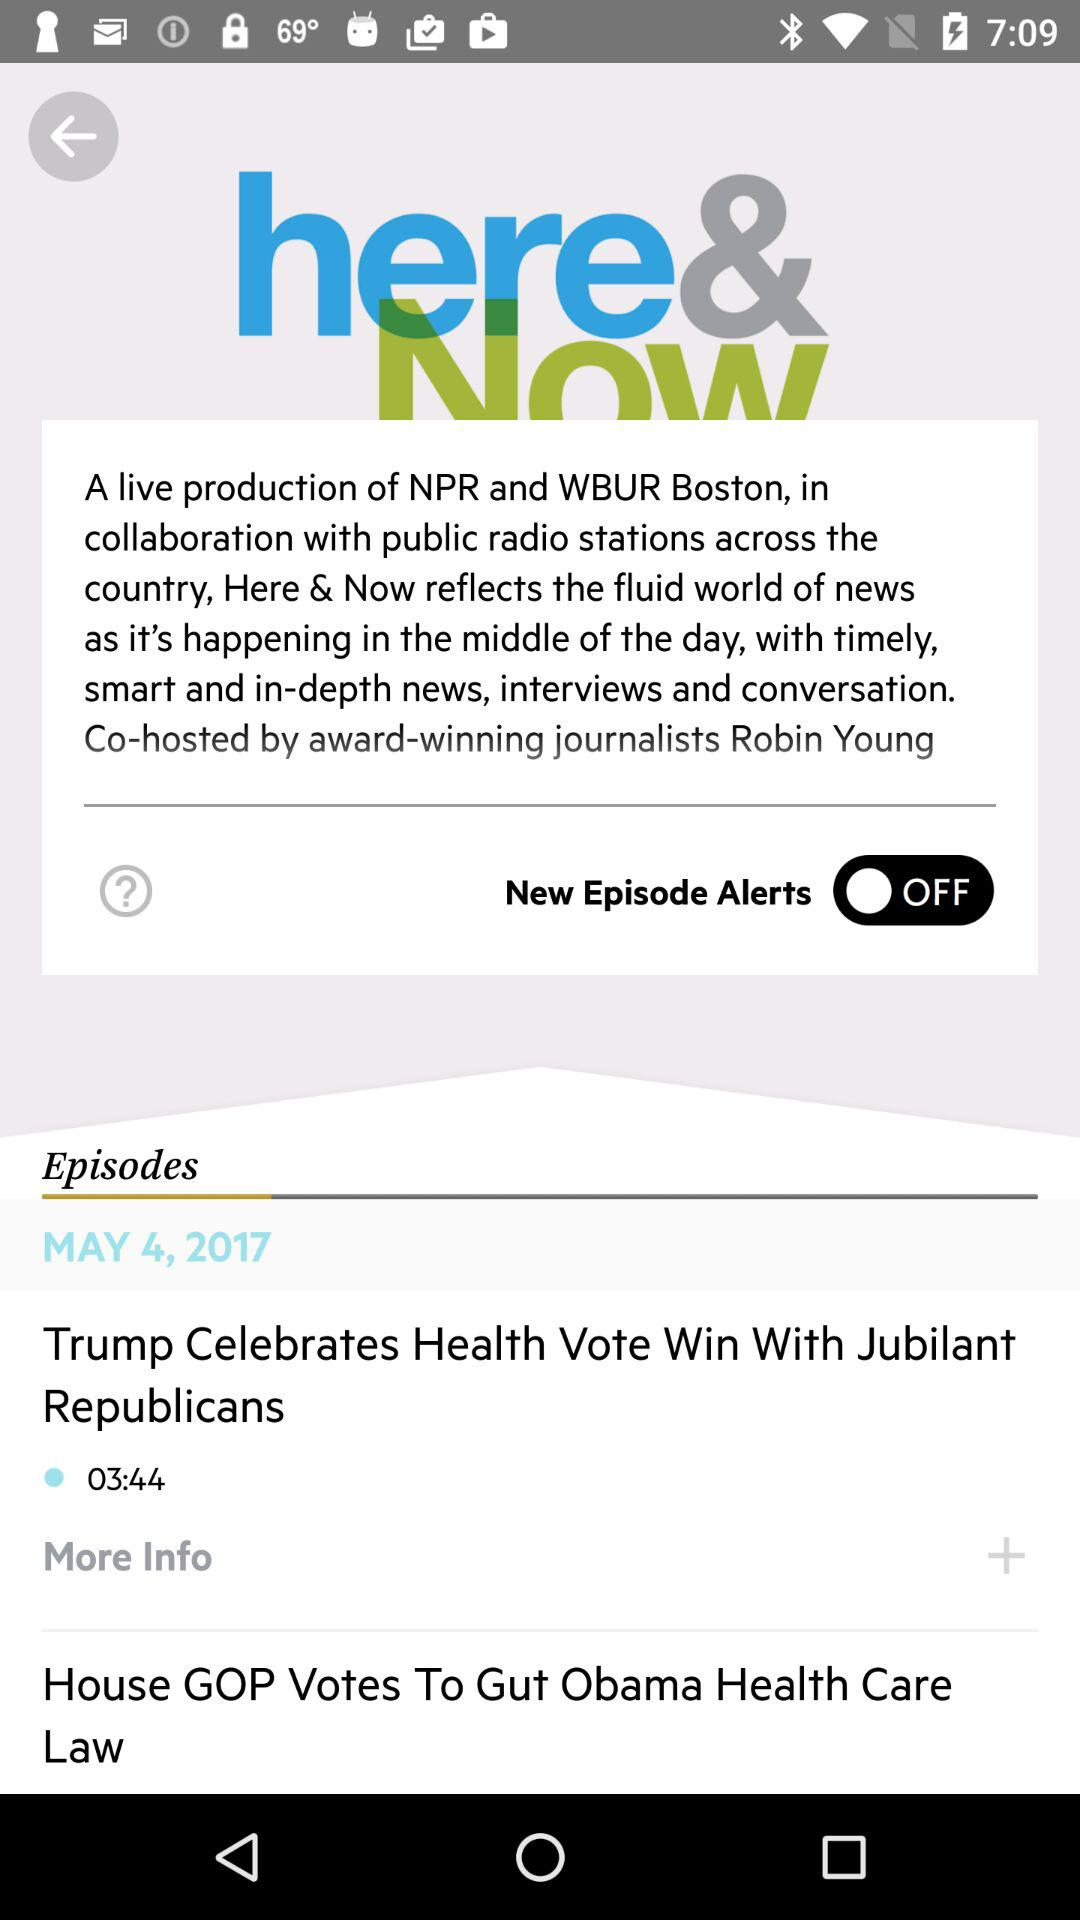When was the episode updated? The episode was updated on May 4, 2017. 